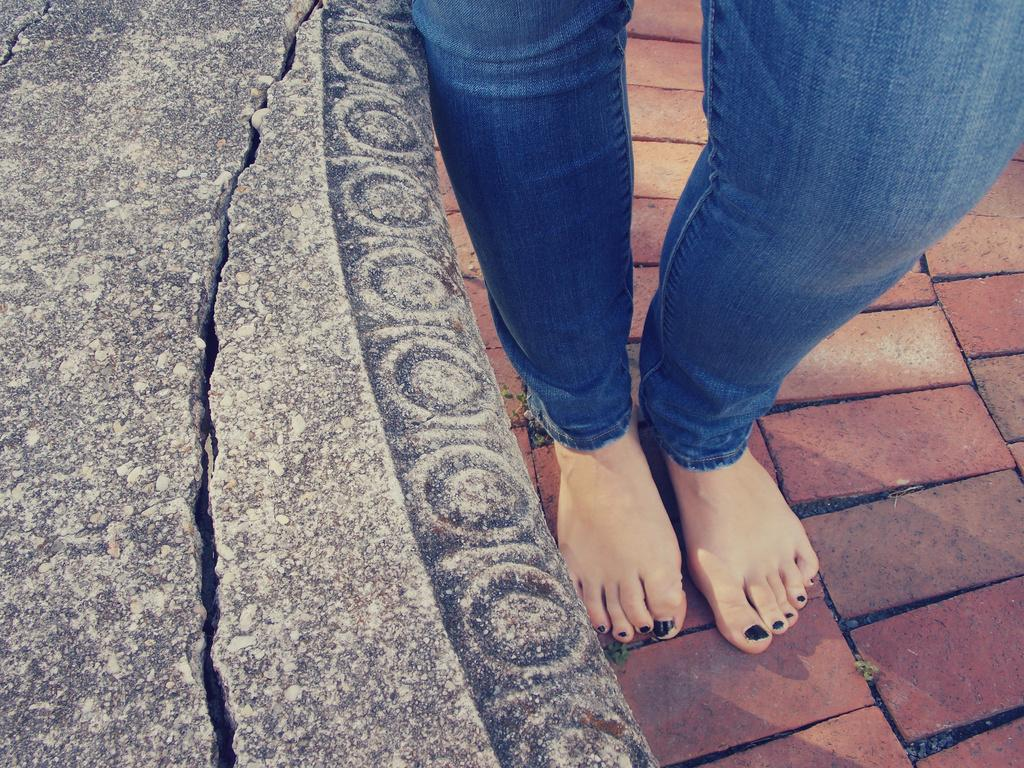What is the condition of the wall on the left side of the image? The wall on the left side of the image is broken. What can be seen on the right side of the image? There are two legs of a person on a footpath on the right side of the image. What type of war is depicted in the image? There is no depiction of war in the image; it only shows a broken wall and two legs on a footpath. What boundary is visible in the image? There is no boundary visible in the image; it only shows a broken wall and two legs on a footpath. 